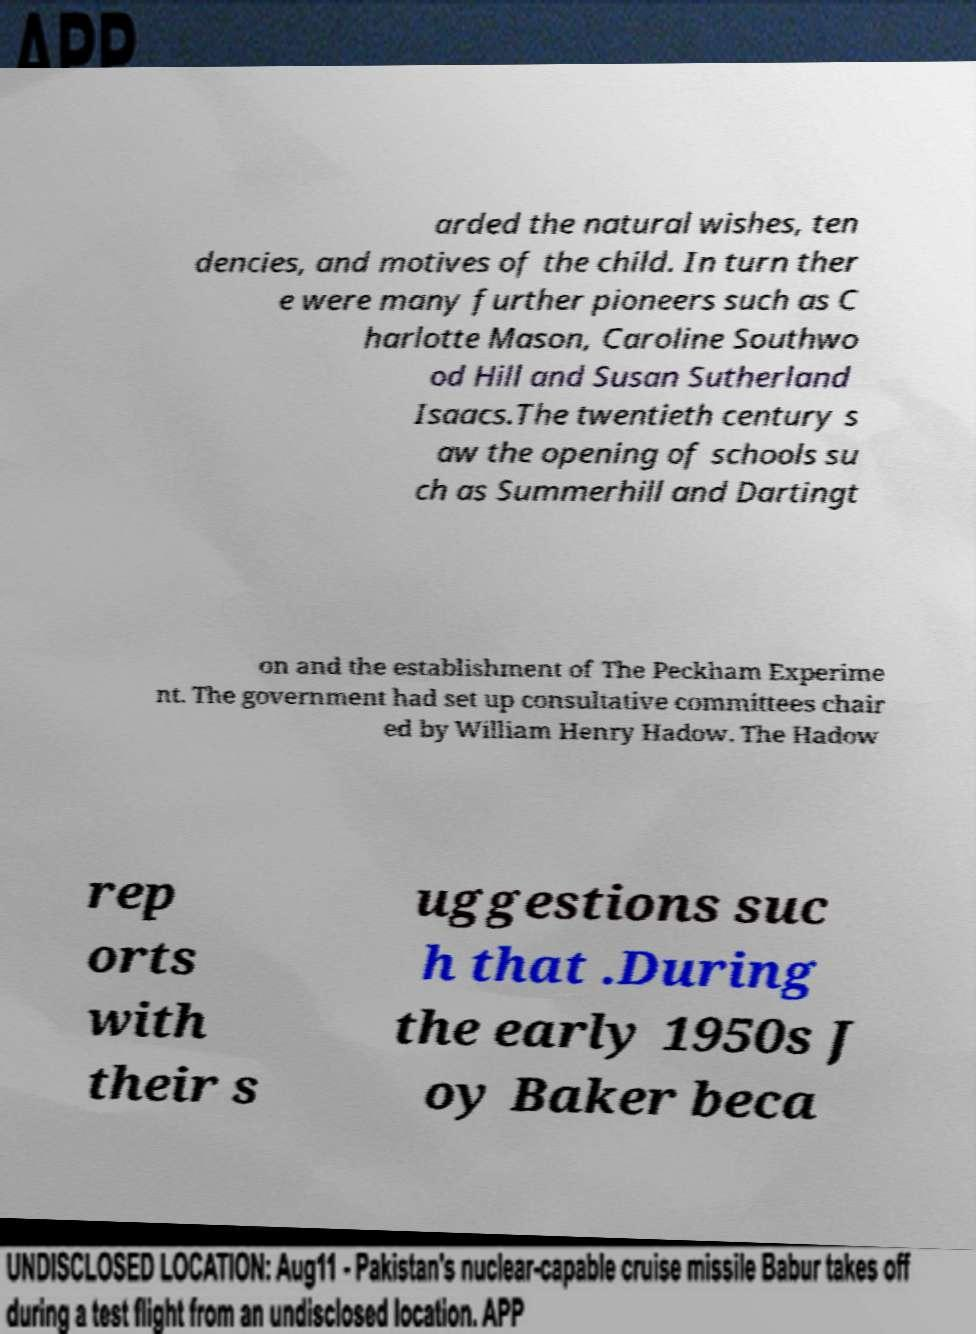What messages or text are displayed in this image? I need them in a readable, typed format. arded the natural wishes, ten dencies, and motives of the child. In turn ther e were many further pioneers such as C harlotte Mason, Caroline Southwo od Hill and Susan Sutherland Isaacs.The twentieth century s aw the opening of schools su ch as Summerhill and Dartingt on and the establishment of The Peckham Experime nt. The government had set up consultative committees chair ed by William Henry Hadow. The Hadow rep orts with their s uggestions suc h that .During the early 1950s J oy Baker beca 